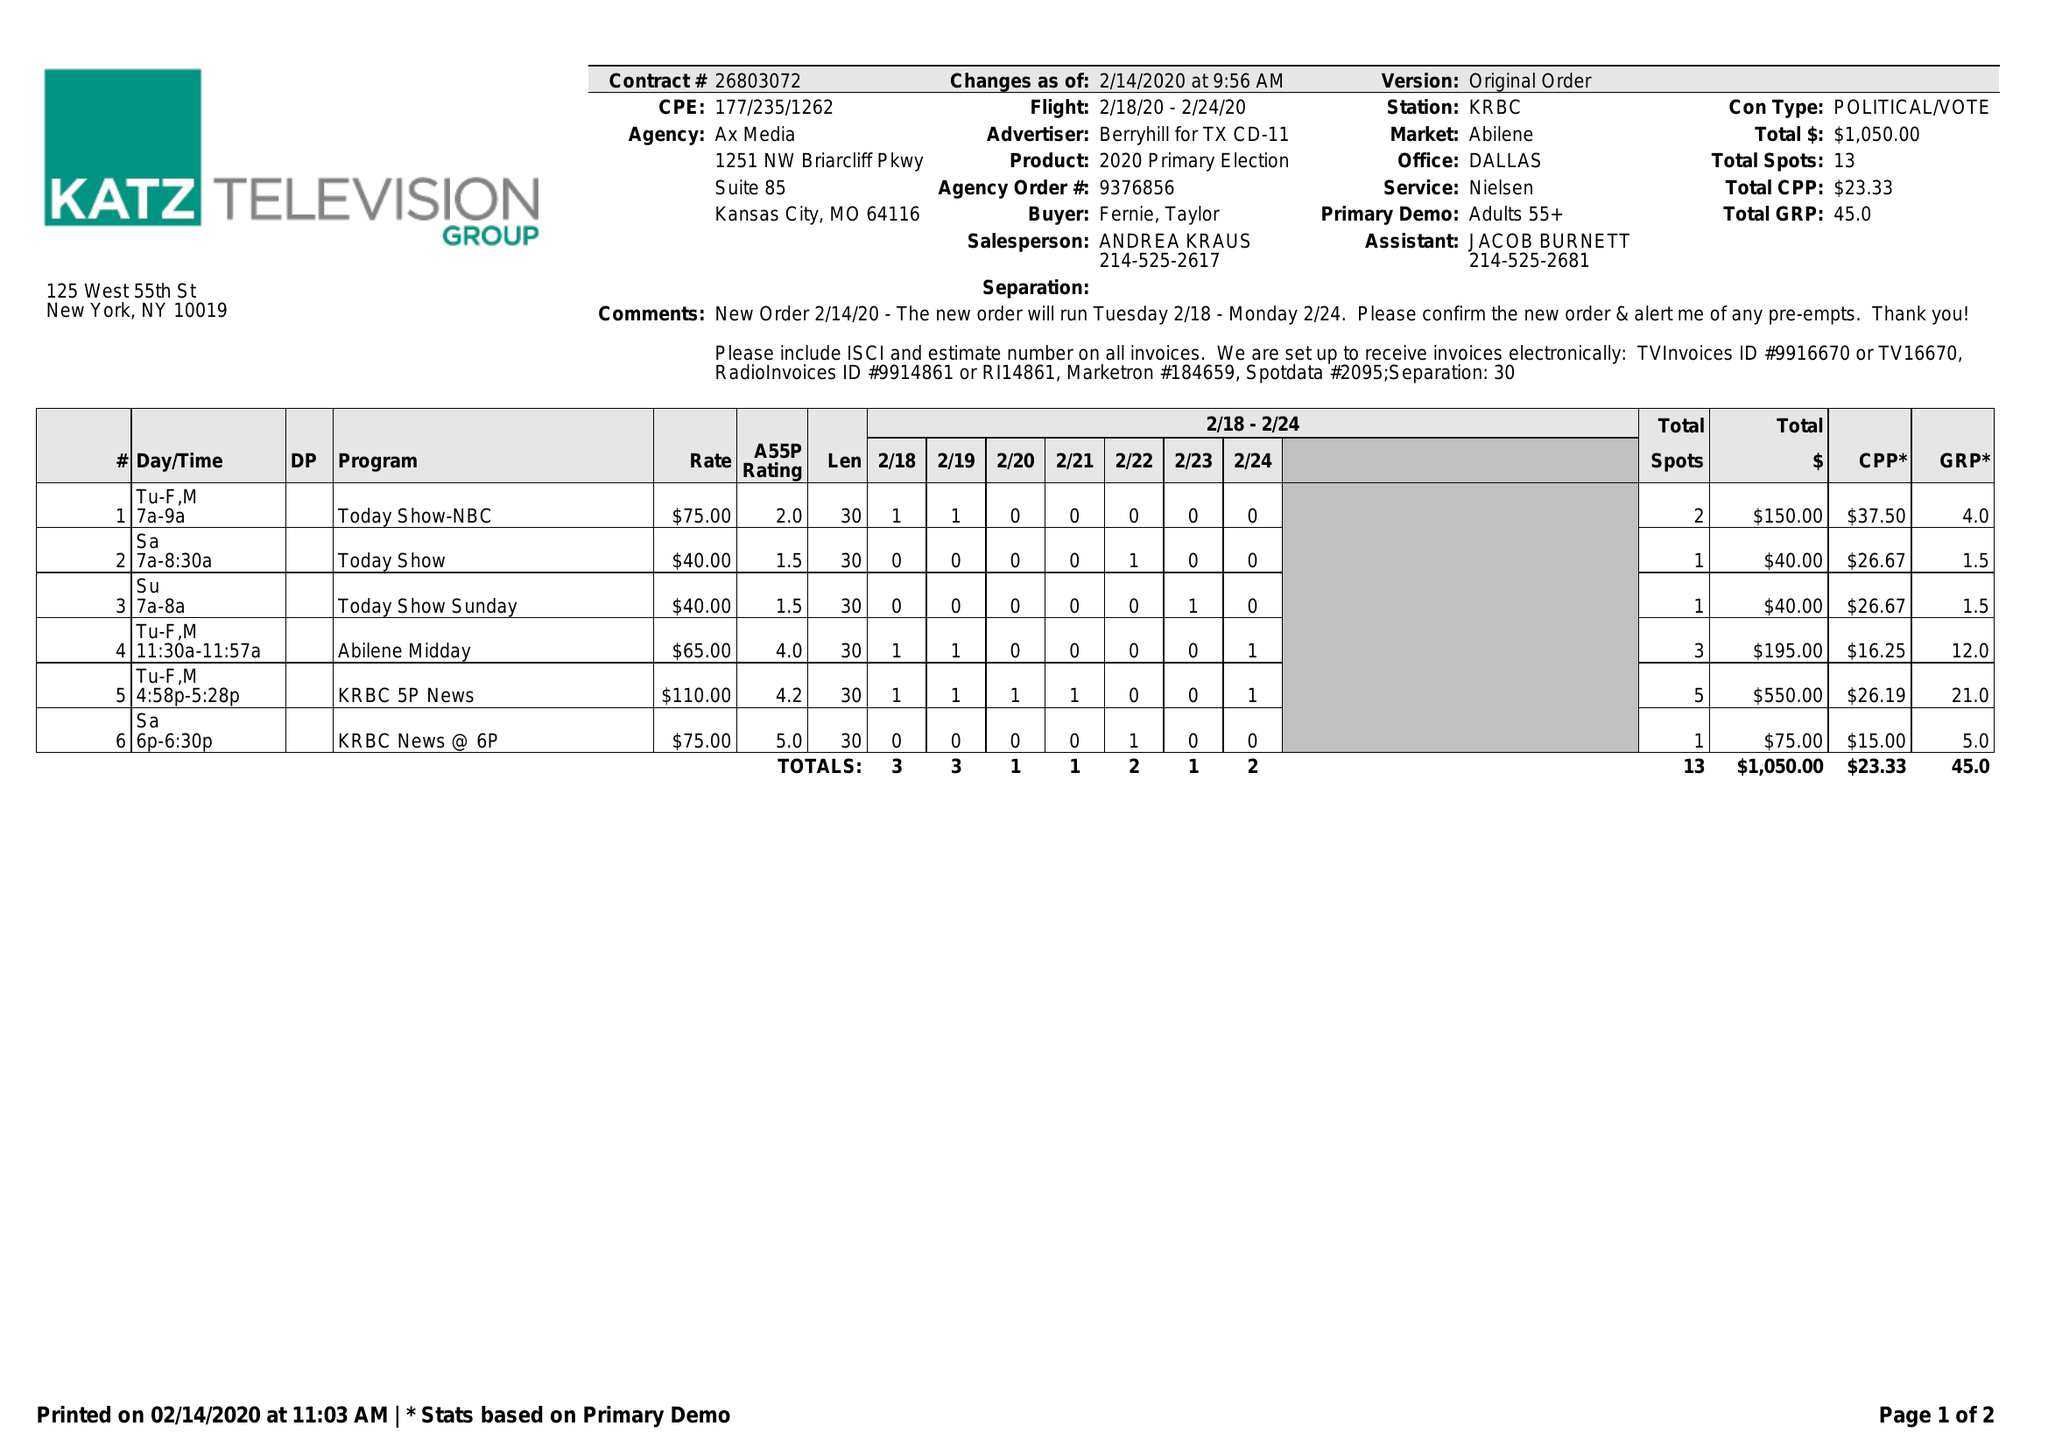What is the value for the contract_num?
Answer the question using a single word or phrase. 26803072 